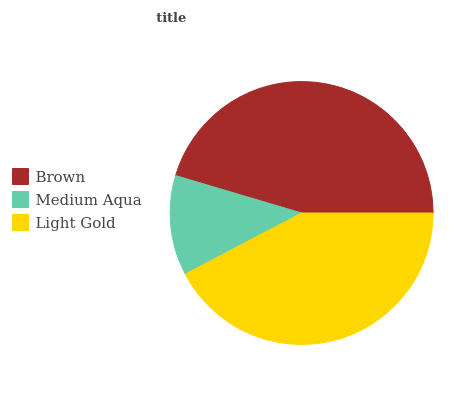Is Medium Aqua the minimum?
Answer yes or no. Yes. Is Brown the maximum?
Answer yes or no. Yes. Is Light Gold the minimum?
Answer yes or no. No. Is Light Gold the maximum?
Answer yes or no. No. Is Light Gold greater than Medium Aqua?
Answer yes or no. Yes. Is Medium Aqua less than Light Gold?
Answer yes or no. Yes. Is Medium Aqua greater than Light Gold?
Answer yes or no. No. Is Light Gold less than Medium Aqua?
Answer yes or no. No. Is Light Gold the high median?
Answer yes or no. Yes. Is Light Gold the low median?
Answer yes or no. Yes. Is Medium Aqua the high median?
Answer yes or no. No. Is Medium Aqua the low median?
Answer yes or no. No. 